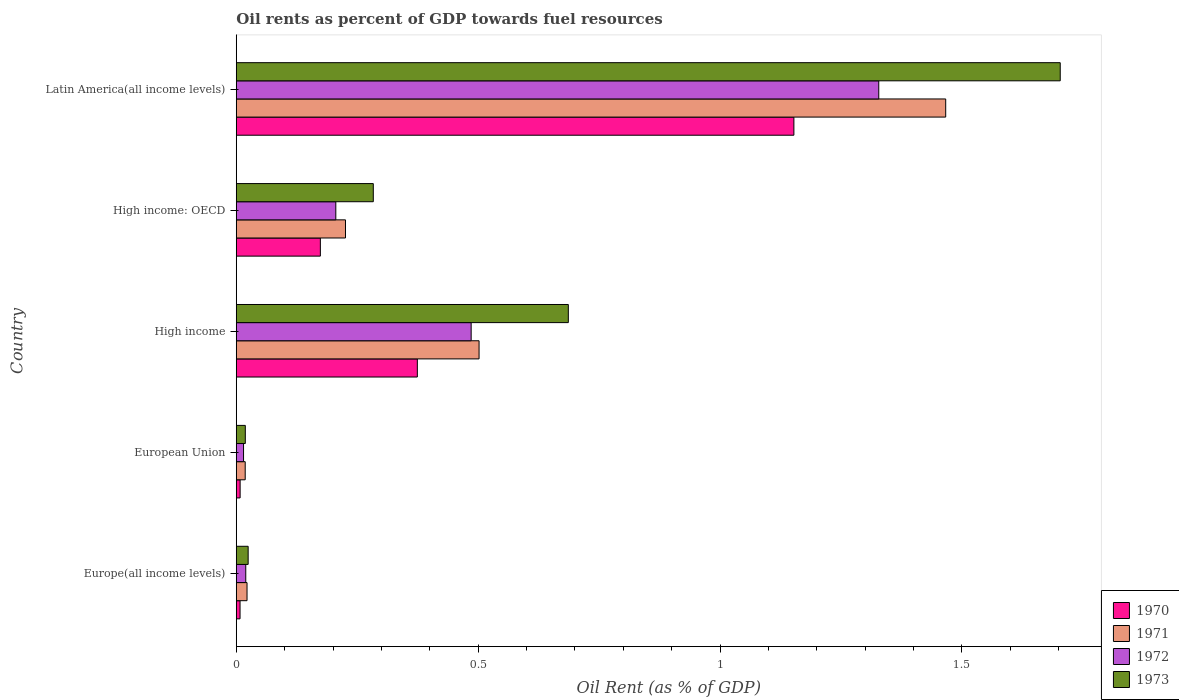How many groups of bars are there?
Offer a terse response. 5. Are the number of bars per tick equal to the number of legend labels?
Provide a short and direct response. Yes. How many bars are there on the 5th tick from the bottom?
Offer a very short reply. 4. In how many cases, is the number of bars for a given country not equal to the number of legend labels?
Offer a terse response. 0. What is the oil rent in 1970 in High income: OECD?
Your response must be concise. 0.17. Across all countries, what is the maximum oil rent in 1970?
Keep it short and to the point. 1.15. Across all countries, what is the minimum oil rent in 1972?
Offer a terse response. 0.02. In which country was the oil rent in 1973 maximum?
Your answer should be compact. Latin America(all income levels). In which country was the oil rent in 1970 minimum?
Offer a very short reply. Europe(all income levels). What is the total oil rent in 1972 in the graph?
Your answer should be very brief. 2.05. What is the difference between the oil rent in 1973 in High income: OECD and that in Latin America(all income levels)?
Offer a very short reply. -1.42. What is the difference between the oil rent in 1971 in Latin America(all income levels) and the oil rent in 1972 in High income: OECD?
Your answer should be very brief. 1.26. What is the average oil rent in 1971 per country?
Offer a terse response. 0.45. What is the difference between the oil rent in 1971 and oil rent in 1970 in European Union?
Offer a terse response. 0.01. What is the ratio of the oil rent in 1972 in Europe(all income levels) to that in Latin America(all income levels)?
Offer a very short reply. 0.01. Is the difference between the oil rent in 1971 in Europe(all income levels) and High income greater than the difference between the oil rent in 1970 in Europe(all income levels) and High income?
Your answer should be very brief. No. What is the difference between the highest and the second highest oil rent in 1971?
Your response must be concise. 0.96. What is the difference between the highest and the lowest oil rent in 1972?
Make the answer very short. 1.31. Is it the case that in every country, the sum of the oil rent in 1973 and oil rent in 1970 is greater than the oil rent in 1971?
Offer a very short reply. Yes. Are all the bars in the graph horizontal?
Keep it short and to the point. Yes. How many countries are there in the graph?
Give a very brief answer. 5. Does the graph contain any zero values?
Your answer should be very brief. No. Does the graph contain grids?
Make the answer very short. No. How are the legend labels stacked?
Offer a terse response. Vertical. What is the title of the graph?
Ensure brevity in your answer.  Oil rents as percent of GDP towards fuel resources. Does "2001" appear as one of the legend labels in the graph?
Give a very brief answer. No. What is the label or title of the X-axis?
Offer a terse response. Oil Rent (as % of GDP). What is the Oil Rent (as % of GDP) in 1970 in Europe(all income levels)?
Provide a succinct answer. 0.01. What is the Oil Rent (as % of GDP) in 1971 in Europe(all income levels)?
Offer a very short reply. 0.02. What is the Oil Rent (as % of GDP) of 1972 in Europe(all income levels)?
Ensure brevity in your answer.  0.02. What is the Oil Rent (as % of GDP) of 1973 in Europe(all income levels)?
Make the answer very short. 0.02. What is the Oil Rent (as % of GDP) of 1970 in European Union?
Your answer should be very brief. 0.01. What is the Oil Rent (as % of GDP) in 1971 in European Union?
Give a very brief answer. 0.02. What is the Oil Rent (as % of GDP) of 1972 in European Union?
Give a very brief answer. 0.02. What is the Oil Rent (as % of GDP) in 1973 in European Union?
Your response must be concise. 0.02. What is the Oil Rent (as % of GDP) in 1970 in High income?
Your answer should be compact. 0.37. What is the Oil Rent (as % of GDP) of 1971 in High income?
Ensure brevity in your answer.  0.5. What is the Oil Rent (as % of GDP) of 1972 in High income?
Offer a terse response. 0.49. What is the Oil Rent (as % of GDP) in 1973 in High income?
Give a very brief answer. 0.69. What is the Oil Rent (as % of GDP) in 1970 in High income: OECD?
Make the answer very short. 0.17. What is the Oil Rent (as % of GDP) in 1971 in High income: OECD?
Your answer should be very brief. 0.23. What is the Oil Rent (as % of GDP) in 1972 in High income: OECD?
Make the answer very short. 0.21. What is the Oil Rent (as % of GDP) in 1973 in High income: OECD?
Your answer should be compact. 0.28. What is the Oil Rent (as % of GDP) in 1970 in Latin America(all income levels)?
Give a very brief answer. 1.15. What is the Oil Rent (as % of GDP) in 1971 in Latin America(all income levels)?
Keep it short and to the point. 1.47. What is the Oil Rent (as % of GDP) in 1972 in Latin America(all income levels)?
Your answer should be compact. 1.33. What is the Oil Rent (as % of GDP) in 1973 in Latin America(all income levels)?
Your answer should be compact. 1.7. Across all countries, what is the maximum Oil Rent (as % of GDP) of 1970?
Your response must be concise. 1.15. Across all countries, what is the maximum Oil Rent (as % of GDP) in 1971?
Your answer should be compact. 1.47. Across all countries, what is the maximum Oil Rent (as % of GDP) of 1972?
Provide a succinct answer. 1.33. Across all countries, what is the maximum Oil Rent (as % of GDP) of 1973?
Keep it short and to the point. 1.7. Across all countries, what is the minimum Oil Rent (as % of GDP) in 1970?
Provide a short and direct response. 0.01. Across all countries, what is the minimum Oil Rent (as % of GDP) in 1971?
Provide a succinct answer. 0.02. Across all countries, what is the minimum Oil Rent (as % of GDP) of 1972?
Offer a very short reply. 0.02. Across all countries, what is the minimum Oil Rent (as % of GDP) of 1973?
Keep it short and to the point. 0.02. What is the total Oil Rent (as % of GDP) of 1970 in the graph?
Make the answer very short. 1.72. What is the total Oil Rent (as % of GDP) in 1971 in the graph?
Your response must be concise. 2.24. What is the total Oil Rent (as % of GDP) of 1972 in the graph?
Keep it short and to the point. 2.05. What is the total Oil Rent (as % of GDP) of 1973 in the graph?
Your response must be concise. 2.72. What is the difference between the Oil Rent (as % of GDP) in 1970 in Europe(all income levels) and that in European Union?
Keep it short and to the point. -0. What is the difference between the Oil Rent (as % of GDP) in 1971 in Europe(all income levels) and that in European Union?
Give a very brief answer. 0. What is the difference between the Oil Rent (as % of GDP) in 1972 in Europe(all income levels) and that in European Union?
Give a very brief answer. 0. What is the difference between the Oil Rent (as % of GDP) in 1973 in Europe(all income levels) and that in European Union?
Give a very brief answer. 0.01. What is the difference between the Oil Rent (as % of GDP) of 1970 in Europe(all income levels) and that in High income?
Ensure brevity in your answer.  -0.37. What is the difference between the Oil Rent (as % of GDP) in 1971 in Europe(all income levels) and that in High income?
Make the answer very short. -0.48. What is the difference between the Oil Rent (as % of GDP) of 1972 in Europe(all income levels) and that in High income?
Keep it short and to the point. -0.47. What is the difference between the Oil Rent (as % of GDP) of 1973 in Europe(all income levels) and that in High income?
Your response must be concise. -0.66. What is the difference between the Oil Rent (as % of GDP) in 1970 in Europe(all income levels) and that in High income: OECD?
Your answer should be very brief. -0.17. What is the difference between the Oil Rent (as % of GDP) of 1971 in Europe(all income levels) and that in High income: OECD?
Keep it short and to the point. -0.2. What is the difference between the Oil Rent (as % of GDP) of 1972 in Europe(all income levels) and that in High income: OECD?
Your response must be concise. -0.19. What is the difference between the Oil Rent (as % of GDP) of 1973 in Europe(all income levels) and that in High income: OECD?
Keep it short and to the point. -0.26. What is the difference between the Oil Rent (as % of GDP) in 1970 in Europe(all income levels) and that in Latin America(all income levels)?
Ensure brevity in your answer.  -1.14. What is the difference between the Oil Rent (as % of GDP) in 1971 in Europe(all income levels) and that in Latin America(all income levels)?
Keep it short and to the point. -1.44. What is the difference between the Oil Rent (as % of GDP) in 1972 in Europe(all income levels) and that in Latin America(all income levels)?
Your answer should be very brief. -1.31. What is the difference between the Oil Rent (as % of GDP) of 1973 in Europe(all income levels) and that in Latin America(all income levels)?
Your answer should be compact. -1.68. What is the difference between the Oil Rent (as % of GDP) in 1970 in European Union and that in High income?
Provide a succinct answer. -0.37. What is the difference between the Oil Rent (as % of GDP) in 1971 in European Union and that in High income?
Your response must be concise. -0.48. What is the difference between the Oil Rent (as % of GDP) in 1972 in European Union and that in High income?
Your answer should be compact. -0.47. What is the difference between the Oil Rent (as % of GDP) of 1973 in European Union and that in High income?
Your answer should be very brief. -0.67. What is the difference between the Oil Rent (as % of GDP) of 1970 in European Union and that in High income: OECD?
Your answer should be very brief. -0.17. What is the difference between the Oil Rent (as % of GDP) of 1971 in European Union and that in High income: OECD?
Provide a short and direct response. -0.21. What is the difference between the Oil Rent (as % of GDP) in 1972 in European Union and that in High income: OECD?
Offer a terse response. -0.19. What is the difference between the Oil Rent (as % of GDP) in 1973 in European Union and that in High income: OECD?
Keep it short and to the point. -0.26. What is the difference between the Oil Rent (as % of GDP) in 1970 in European Union and that in Latin America(all income levels)?
Keep it short and to the point. -1.14. What is the difference between the Oil Rent (as % of GDP) of 1971 in European Union and that in Latin America(all income levels)?
Make the answer very short. -1.45. What is the difference between the Oil Rent (as % of GDP) of 1972 in European Union and that in Latin America(all income levels)?
Ensure brevity in your answer.  -1.31. What is the difference between the Oil Rent (as % of GDP) of 1973 in European Union and that in Latin America(all income levels)?
Make the answer very short. -1.68. What is the difference between the Oil Rent (as % of GDP) in 1970 in High income and that in High income: OECD?
Provide a short and direct response. 0.2. What is the difference between the Oil Rent (as % of GDP) in 1971 in High income and that in High income: OECD?
Provide a short and direct response. 0.28. What is the difference between the Oil Rent (as % of GDP) of 1972 in High income and that in High income: OECD?
Your response must be concise. 0.28. What is the difference between the Oil Rent (as % of GDP) of 1973 in High income and that in High income: OECD?
Your answer should be compact. 0.4. What is the difference between the Oil Rent (as % of GDP) of 1970 in High income and that in Latin America(all income levels)?
Your answer should be very brief. -0.78. What is the difference between the Oil Rent (as % of GDP) of 1971 in High income and that in Latin America(all income levels)?
Your response must be concise. -0.96. What is the difference between the Oil Rent (as % of GDP) of 1972 in High income and that in Latin America(all income levels)?
Your answer should be compact. -0.84. What is the difference between the Oil Rent (as % of GDP) of 1973 in High income and that in Latin America(all income levels)?
Your answer should be compact. -1.02. What is the difference between the Oil Rent (as % of GDP) of 1970 in High income: OECD and that in Latin America(all income levels)?
Your answer should be compact. -0.98. What is the difference between the Oil Rent (as % of GDP) of 1971 in High income: OECD and that in Latin America(all income levels)?
Make the answer very short. -1.24. What is the difference between the Oil Rent (as % of GDP) in 1972 in High income: OECD and that in Latin America(all income levels)?
Your response must be concise. -1.12. What is the difference between the Oil Rent (as % of GDP) of 1973 in High income: OECD and that in Latin America(all income levels)?
Your answer should be very brief. -1.42. What is the difference between the Oil Rent (as % of GDP) of 1970 in Europe(all income levels) and the Oil Rent (as % of GDP) of 1971 in European Union?
Give a very brief answer. -0.01. What is the difference between the Oil Rent (as % of GDP) of 1970 in Europe(all income levels) and the Oil Rent (as % of GDP) of 1972 in European Union?
Give a very brief answer. -0.01. What is the difference between the Oil Rent (as % of GDP) in 1970 in Europe(all income levels) and the Oil Rent (as % of GDP) in 1973 in European Union?
Ensure brevity in your answer.  -0.01. What is the difference between the Oil Rent (as % of GDP) of 1971 in Europe(all income levels) and the Oil Rent (as % of GDP) of 1972 in European Union?
Keep it short and to the point. 0.01. What is the difference between the Oil Rent (as % of GDP) of 1971 in Europe(all income levels) and the Oil Rent (as % of GDP) of 1973 in European Union?
Give a very brief answer. 0. What is the difference between the Oil Rent (as % of GDP) of 1972 in Europe(all income levels) and the Oil Rent (as % of GDP) of 1973 in European Union?
Your answer should be compact. 0. What is the difference between the Oil Rent (as % of GDP) in 1970 in Europe(all income levels) and the Oil Rent (as % of GDP) in 1971 in High income?
Keep it short and to the point. -0.49. What is the difference between the Oil Rent (as % of GDP) of 1970 in Europe(all income levels) and the Oil Rent (as % of GDP) of 1972 in High income?
Give a very brief answer. -0.48. What is the difference between the Oil Rent (as % of GDP) of 1970 in Europe(all income levels) and the Oil Rent (as % of GDP) of 1973 in High income?
Provide a short and direct response. -0.68. What is the difference between the Oil Rent (as % of GDP) in 1971 in Europe(all income levels) and the Oil Rent (as % of GDP) in 1972 in High income?
Offer a terse response. -0.46. What is the difference between the Oil Rent (as % of GDP) in 1971 in Europe(all income levels) and the Oil Rent (as % of GDP) in 1973 in High income?
Offer a very short reply. -0.66. What is the difference between the Oil Rent (as % of GDP) in 1972 in Europe(all income levels) and the Oil Rent (as % of GDP) in 1973 in High income?
Give a very brief answer. -0.67. What is the difference between the Oil Rent (as % of GDP) of 1970 in Europe(all income levels) and the Oil Rent (as % of GDP) of 1971 in High income: OECD?
Your answer should be compact. -0.22. What is the difference between the Oil Rent (as % of GDP) in 1970 in Europe(all income levels) and the Oil Rent (as % of GDP) in 1972 in High income: OECD?
Offer a terse response. -0.2. What is the difference between the Oil Rent (as % of GDP) in 1970 in Europe(all income levels) and the Oil Rent (as % of GDP) in 1973 in High income: OECD?
Make the answer very short. -0.28. What is the difference between the Oil Rent (as % of GDP) of 1971 in Europe(all income levels) and the Oil Rent (as % of GDP) of 1972 in High income: OECD?
Make the answer very short. -0.18. What is the difference between the Oil Rent (as % of GDP) of 1971 in Europe(all income levels) and the Oil Rent (as % of GDP) of 1973 in High income: OECD?
Make the answer very short. -0.26. What is the difference between the Oil Rent (as % of GDP) in 1972 in Europe(all income levels) and the Oil Rent (as % of GDP) in 1973 in High income: OECD?
Offer a terse response. -0.26. What is the difference between the Oil Rent (as % of GDP) in 1970 in Europe(all income levels) and the Oil Rent (as % of GDP) in 1971 in Latin America(all income levels)?
Give a very brief answer. -1.46. What is the difference between the Oil Rent (as % of GDP) in 1970 in Europe(all income levels) and the Oil Rent (as % of GDP) in 1972 in Latin America(all income levels)?
Your answer should be compact. -1.32. What is the difference between the Oil Rent (as % of GDP) of 1970 in Europe(all income levels) and the Oil Rent (as % of GDP) of 1973 in Latin America(all income levels)?
Ensure brevity in your answer.  -1.7. What is the difference between the Oil Rent (as % of GDP) of 1971 in Europe(all income levels) and the Oil Rent (as % of GDP) of 1972 in Latin America(all income levels)?
Your answer should be very brief. -1.31. What is the difference between the Oil Rent (as % of GDP) of 1971 in Europe(all income levels) and the Oil Rent (as % of GDP) of 1973 in Latin America(all income levels)?
Make the answer very short. -1.68. What is the difference between the Oil Rent (as % of GDP) of 1972 in Europe(all income levels) and the Oil Rent (as % of GDP) of 1973 in Latin America(all income levels)?
Offer a very short reply. -1.68. What is the difference between the Oil Rent (as % of GDP) of 1970 in European Union and the Oil Rent (as % of GDP) of 1971 in High income?
Ensure brevity in your answer.  -0.49. What is the difference between the Oil Rent (as % of GDP) in 1970 in European Union and the Oil Rent (as % of GDP) in 1972 in High income?
Keep it short and to the point. -0.48. What is the difference between the Oil Rent (as % of GDP) of 1970 in European Union and the Oil Rent (as % of GDP) of 1973 in High income?
Your response must be concise. -0.68. What is the difference between the Oil Rent (as % of GDP) of 1971 in European Union and the Oil Rent (as % of GDP) of 1972 in High income?
Give a very brief answer. -0.47. What is the difference between the Oil Rent (as % of GDP) of 1971 in European Union and the Oil Rent (as % of GDP) of 1973 in High income?
Your answer should be very brief. -0.67. What is the difference between the Oil Rent (as % of GDP) in 1972 in European Union and the Oil Rent (as % of GDP) in 1973 in High income?
Your response must be concise. -0.67. What is the difference between the Oil Rent (as % of GDP) in 1970 in European Union and the Oil Rent (as % of GDP) in 1971 in High income: OECD?
Ensure brevity in your answer.  -0.22. What is the difference between the Oil Rent (as % of GDP) of 1970 in European Union and the Oil Rent (as % of GDP) of 1972 in High income: OECD?
Give a very brief answer. -0.2. What is the difference between the Oil Rent (as % of GDP) in 1970 in European Union and the Oil Rent (as % of GDP) in 1973 in High income: OECD?
Provide a succinct answer. -0.28. What is the difference between the Oil Rent (as % of GDP) in 1971 in European Union and the Oil Rent (as % of GDP) in 1972 in High income: OECD?
Your answer should be compact. -0.19. What is the difference between the Oil Rent (as % of GDP) in 1971 in European Union and the Oil Rent (as % of GDP) in 1973 in High income: OECD?
Your answer should be compact. -0.26. What is the difference between the Oil Rent (as % of GDP) in 1972 in European Union and the Oil Rent (as % of GDP) in 1973 in High income: OECD?
Ensure brevity in your answer.  -0.27. What is the difference between the Oil Rent (as % of GDP) of 1970 in European Union and the Oil Rent (as % of GDP) of 1971 in Latin America(all income levels)?
Ensure brevity in your answer.  -1.46. What is the difference between the Oil Rent (as % of GDP) in 1970 in European Union and the Oil Rent (as % of GDP) in 1972 in Latin America(all income levels)?
Ensure brevity in your answer.  -1.32. What is the difference between the Oil Rent (as % of GDP) of 1970 in European Union and the Oil Rent (as % of GDP) of 1973 in Latin America(all income levels)?
Give a very brief answer. -1.7. What is the difference between the Oil Rent (as % of GDP) of 1971 in European Union and the Oil Rent (as % of GDP) of 1972 in Latin America(all income levels)?
Your response must be concise. -1.31. What is the difference between the Oil Rent (as % of GDP) in 1971 in European Union and the Oil Rent (as % of GDP) in 1973 in Latin America(all income levels)?
Offer a terse response. -1.68. What is the difference between the Oil Rent (as % of GDP) of 1972 in European Union and the Oil Rent (as % of GDP) of 1973 in Latin America(all income levels)?
Your answer should be compact. -1.69. What is the difference between the Oil Rent (as % of GDP) of 1970 in High income and the Oil Rent (as % of GDP) of 1971 in High income: OECD?
Your answer should be very brief. 0.15. What is the difference between the Oil Rent (as % of GDP) of 1970 in High income and the Oil Rent (as % of GDP) of 1972 in High income: OECD?
Your answer should be compact. 0.17. What is the difference between the Oil Rent (as % of GDP) of 1970 in High income and the Oil Rent (as % of GDP) of 1973 in High income: OECD?
Your response must be concise. 0.09. What is the difference between the Oil Rent (as % of GDP) of 1971 in High income and the Oil Rent (as % of GDP) of 1972 in High income: OECD?
Offer a very short reply. 0.3. What is the difference between the Oil Rent (as % of GDP) of 1971 in High income and the Oil Rent (as % of GDP) of 1973 in High income: OECD?
Keep it short and to the point. 0.22. What is the difference between the Oil Rent (as % of GDP) of 1972 in High income and the Oil Rent (as % of GDP) of 1973 in High income: OECD?
Your answer should be very brief. 0.2. What is the difference between the Oil Rent (as % of GDP) of 1970 in High income and the Oil Rent (as % of GDP) of 1971 in Latin America(all income levels)?
Offer a terse response. -1.09. What is the difference between the Oil Rent (as % of GDP) of 1970 in High income and the Oil Rent (as % of GDP) of 1972 in Latin America(all income levels)?
Provide a short and direct response. -0.95. What is the difference between the Oil Rent (as % of GDP) in 1970 in High income and the Oil Rent (as % of GDP) in 1973 in Latin America(all income levels)?
Provide a succinct answer. -1.33. What is the difference between the Oil Rent (as % of GDP) in 1971 in High income and the Oil Rent (as % of GDP) in 1972 in Latin America(all income levels)?
Give a very brief answer. -0.83. What is the difference between the Oil Rent (as % of GDP) in 1971 in High income and the Oil Rent (as % of GDP) in 1973 in Latin America(all income levels)?
Your answer should be compact. -1.2. What is the difference between the Oil Rent (as % of GDP) of 1972 in High income and the Oil Rent (as % of GDP) of 1973 in Latin America(all income levels)?
Ensure brevity in your answer.  -1.22. What is the difference between the Oil Rent (as % of GDP) of 1970 in High income: OECD and the Oil Rent (as % of GDP) of 1971 in Latin America(all income levels)?
Provide a succinct answer. -1.29. What is the difference between the Oil Rent (as % of GDP) in 1970 in High income: OECD and the Oil Rent (as % of GDP) in 1972 in Latin America(all income levels)?
Ensure brevity in your answer.  -1.15. What is the difference between the Oil Rent (as % of GDP) of 1970 in High income: OECD and the Oil Rent (as % of GDP) of 1973 in Latin America(all income levels)?
Your response must be concise. -1.53. What is the difference between the Oil Rent (as % of GDP) in 1971 in High income: OECD and the Oil Rent (as % of GDP) in 1972 in Latin America(all income levels)?
Give a very brief answer. -1.1. What is the difference between the Oil Rent (as % of GDP) of 1971 in High income: OECD and the Oil Rent (as % of GDP) of 1973 in Latin America(all income levels)?
Ensure brevity in your answer.  -1.48. What is the difference between the Oil Rent (as % of GDP) in 1972 in High income: OECD and the Oil Rent (as % of GDP) in 1973 in Latin America(all income levels)?
Offer a terse response. -1.5. What is the average Oil Rent (as % of GDP) of 1970 per country?
Your response must be concise. 0.34. What is the average Oil Rent (as % of GDP) of 1971 per country?
Provide a succinct answer. 0.45. What is the average Oil Rent (as % of GDP) of 1972 per country?
Make the answer very short. 0.41. What is the average Oil Rent (as % of GDP) in 1973 per country?
Your response must be concise. 0.54. What is the difference between the Oil Rent (as % of GDP) of 1970 and Oil Rent (as % of GDP) of 1971 in Europe(all income levels)?
Make the answer very short. -0.01. What is the difference between the Oil Rent (as % of GDP) of 1970 and Oil Rent (as % of GDP) of 1972 in Europe(all income levels)?
Provide a short and direct response. -0.01. What is the difference between the Oil Rent (as % of GDP) of 1970 and Oil Rent (as % of GDP) of 1973 in Europe(all income levels)?
Provide a succinct answer. -0.02. What is the difference between the Oil Rent (as % of GDP) of 1971 and Oil Rent (as % of GDP) of 1972 in Europe(all income levels)?
Your response must be concise. 0. What is the difference between the Oil Rent (as % of GDP) of 1971 and Oil Rent (as % of GDP) of 1973 in Europe(all income levels)?
Your answer should be compact. -0. What is the difference between the Oil Rent (as % of GDP) in 1972 and Oil Rent (as % of GDP) in 1973 in Europe(all income levels)?
Your response must be concise. -0.01. What is the difference between the Oil Rent (as % of GDP) in 1970 and Oil Rent (as % of GDP) in 1971 in European Union?
Keep it short and to the point. -0.01. What is the difference between the Oil Rent (as % of GDP) of 1970 and Oil Rent (as % of GDP) of 1972 in European Union?
Provide a succinct answer. -0.01. What is the difference between the Oil Rent (as % of GDP) in 1970 and Oil Rent (as % of GDP) in 1973 in European Union?
Provide a succinct answer. -0.01. What is the difference between the Oil Rent (as % of GDP) in 1971 and Oil Rent (as % of GDP) in 1972 in European Union?
Ensure brevity in your answer.  0. What is the difference between the Oil Rent (as % of GDP) of 1971 and Oil Rent (as % of GDP) of 1973 in European Union?
Provide a succinct answer. -0. What is the difference between the Oil Rent (as % of GDP) of 1972 and Oil Rent (as % of GDP) of 1973 in European Union?
Make the answer very short. -0. What is the difference between the Oil Rent (as % of GDP) in 1970 and Oil Rent (as % of GDP) in 1971 in High income?
Offer a terse response. -0.13. What is the difference between the Oil Rent (as % of GDP) of 1970 and Oil Rent (as % of GDP) of 1972 in High income?
Provide a short and direct response. -0.11. What is the difference between the Oil Rent (as % of GDP) of 1970 and Oil Rent (as % of GDP) of 1973 in High income?
Offer a very short reply. -0.31. What is the difference between the Oil Rent (as % of GDP) of 1971 and Oil Rent (as % of GDP) of 1972 in High income?
Ensure brevity in your answer.  0.02. What is the difference between the Oil Rent (as % of GDP) in 1971 and Oil Rent (as % of GDP) in 1973 in High income?
Your answer should be compact. -0.18. What is the difference between the Oil Rent (as % of GDP) of 1972 and Oil Rent (as % of GDP) of 1973 in High income?
Provide a succinct answer. -0.2. What is the difference between the Oil Rent (as % of GDP) in 1970 and Oil Rent (as % of GDP) in 1971 in High income: OECD?
Make the answer very short. -0.05. What is the difference between the Oil Rent (as % of GDP) of 1970 and Oil Rent (as % of GDP) of 1972 in High income: OECD?
Your response must be concise. -0.03. What is the difference between the Oil Rent (as % of GDP) of 1970 and Oil Rent (as % of GDP) of 1973 in High income: OECD?
Offer a very short reply. -0.11. What is the difference between the Oil Rent (as % of GDP) of 1971 and Oil Rent (as % of GDP) of 1973 in High income: OECD?
Provide a short and direct response. -0.06. What is the difference between the Oil Rent (as % of GDP) in 1972 and Oil Rent (as % of GDP) in 1973 in High income: OECD?
Ensure brevity in your answer.  -0.08. What is the difference between the Oil Rent (as % of GDP) in 1970 and Oil Rent (as % of GDP) in 1971 in Latin America(all income levels)?
Offer a terse response. -0.31. What is the difference between the Oil Rent (as % of GDP) of 1970 and Oil Rent (as % of GDP) of 1972 in Latin America(all income levels)?
Your answer should be compact. -0.18. What is the difference between the Oil Rent (as % of GDP) in 1970 and Oil Rent (as % of GDP) in 1973 in Latin America(all income levels)?
Give a very brief answer. -0.55. What is the difference between the Oil Rent (as % of GDP) in 1971 and Oil Rent (as % of GDP) in 1972 in Latin America(all income levels)?
Provide a succinct answer. 0.14. What is the difference between the Oil Rent (as % of GDP) in 1971 and Oil Rent (as % of GDP) in 1973 in Latin America(all income levels)?
Offer a terse response. -0.24. What is the difference between the Oil Rent (as % of GDP) in 1972 and Oil Rent (as % of GDP) in 1973 in Latin America(all income levels)?
Offer a terse response. -0.38. What is the ratio of the Oil Rent (as % of GDP) of 1970 in Europe(all income levels) to that in European Union?
Give a very brief answer. 0.98. What is the ratio of the Oil Rent (as % of GDP) of 1971 in Europe(all income levels) to that in European Union?
Offer a very short reply. 1.2. What is the ratio of the Oil Rent (as % of GDP) in 1972 in Europe(all income levels) to that in European Union?
Provide a succinct answer. 1.3. What is the ratio of the Oil Rent (as % of GDP) in 1973 in Europe(all income levels) to that in European Union?
Your answer should be very brief. 1.31. What is the ratio of the Oil Rent (as % of GDP) in 1970 in Europe(all income levels) to that in High income?
Provide a short and direct response. 0.02. What is the ratio of the Oil Rent (as % of GDP) of 1971 in Europe(all income levels) to that in High income?
Your answer should be compact. 0.04. What is the ratio of the Oil Rent (as % of GDP) in 1972 in Europe(all income levels) to that in High income?
Ensure brevity in your answer.  0.04. What is the ratio of the Oil Rent (as % of GDP) of 1973 in Europe(all income levels) to that in High income?
Give a very brief answer. 0.04. What is the ratio of the Oil Rent (as % of GDP) in 1970 in Europe(all income levels) to that in High income: OECD?
Offer a very short reply. 0.05. What is the ratio of the Oil Rent (as % of GDP) of 1971 in Europe(all income levels) to that in High income: OECD?
Ensure brevity in your answer.  0.1. What is the ratio of the Oil Rent (as % of GDP) in 1972 in Europe(all income levels) to that in High income: OECD?
Give a very brief answer. 0.1. What is the ratio of the Oil Rent (as % of GDP) of 1973 in Europe(all income levels) to that in High income: OECD?
Your response must be concise. 0.09. What is the ratio of the Oil Rent (as % of GDP) of 1970 in Europe(all income levels) to that in Latin America(all income levels)?
Ensure brevity in your answer.  0.01. What is the ratio of the Oil Rent (as % of GDP) in 1971 in Europe(all income levels) to that in Latin America(all income levels)?
Keep it short and to the point. 0.02. What is the ratio of the Oil Rent (as % of GDP) in 1972 in Europe(all income levels) to that in Latin America(all income levels)?
Your answer should be very brief. 0.01. What is the ratio of the Oil Rent (as % of GDP) in 1973 in Europe(all income levels) to that in Latin America(all income levels)?
Give a very brief answer. 0.01. What is the ratio of the Oil Rent (as % of GDP) of 1970 in European Union to that in High income?
Offer a terse response. 0.02. What is the ratio of the Oil Rent (as % of GDP) of 1971 in European Union to that in High income?
Your answer should be very brief. 0.04. What is the ratio of the Oil Rent (as % of GDP) in 1972 in European Union to that in High income?
Your answer should be very brief. 0.03. What is the ratio of the Oil Rent (as % of GDP) of 1973 in European Union to that in High income?
Keep it short and to the point. 0.03. What is the ratio of the Oil Rent (as % of GDP) in 1970 in European Union to that in High income: OECD?
Provide a short and direct response. 0.05. What is the ratio of the Oil Rent (as % of GDP) of 1971 in European Union to that in High income: OECD?
Make the answer very short. 0.08. What is the ratio of the Oil Rent (as % of GDP) in 1972 in European Union to that in High income: OECD?
Provide a succinct answer. 0.07. What is the ratio of the Oil Rent (as % of GDP) in 1973 in European Union to that in High income: OECD?
Make the answer very short. 0.07. What is the ratio of the Oil Rent (as % of GDP) of 1970 in European Union to that in Latin America(all income levels)?
Your answer should be very brief. 0.01. What is the ratio of the Oil Rent (as % of GDP) of 1971 in European Union to that in Latin America(all income levels)?
Your response must be concise. 0.01. What is the ratio of the Oil Rent (as % of GDP) in 1972 in European Union to that in Latin America(all income levels)?
Make the answer very short. 0.01. What is the ratio of the Oil Rent (as % of GDP) in 1973 in European Union to that in Latin America(all income levels)?
Provide a succinct answer. 0.01. What is the ratio of the Oil Rent (as % of GDP) of 1970 in High income to that in High income: OECD?
Your answer should be compact. 2.15. What is the ratio of the Oil Rent (as % of GDP) of 1971 in High income to that in High income: OECD?
Your answer should be compact. 2.22. What is the ratio of the Oil Rent (as % of GDP) of 1972 in High income to that in High income: OECD?
Offer a terse response. 2.36. What is the ratio of the Oil Rent (as % of GDP) of 1973 in High income to that in High income: OECD?
Offer a terse response. 2.42. What is the ratio of the Oil Rent (as % of GDP) of 1970 in High income to that in Latin America(all income levels)?
Offer a terse response. 0.32. What is the ratio of the Oil Rent (as % of GDP) in 1971 in High income to that in Latin America(all income levels)?
Provide a short and direct response. 0.34. What is the ratio of the Oil Rent (as % of GDP) in 1972 in High income to that in Latin America(all income levels)?
Your answer should be compact. 0.37. What is the ratio of the Oil Rent (as % of GDP) of 1973 in High income to that in Latin America(all income levels)?
Make the answer very short. 0.4. What is the ratio of the Oil Rent (as % of GDP) in 1970 in High income: OECD to that in Latin America(all income levels)?
Ensure brevity in your answer.  0.15. What is the ratio of the Oil Rent (as % of GDP) of 1971 in High income: OECD to that in Latin America(all income levels)?
Your answer should be compact. 0.15. What is the ratio of the Oil Rent (as % of GDP) of 1972 in High income: OECD to that in Latin America(all income levels)?
Ensure brevity in your answer.  0.15. What is the ratio of the Oil Rent (as % of GDP) of 1973 in High income: OECD to that in Latin America(all income levels)?
Give a very brief answer. 0.17. What is the difference between the highest and the second highest Oil Rent (as % of GDP) in 1970?
Make the answer very short. 0.78. What is the difference between the highest and the second highest Oil Rent (as % of GDP) of 1971?
Keep it short and to the point. 0.96. What is the difference between the highest and the second highest Oil Rent (as % of GDP) in 1972?
Offer a terse response. 0.84. What is the difference between the highest and the second highest Oil Rent (as % of GDP) of 1973?
Give a very brief answer. 1.02. What is the difference between the highest and the lowest Oil Rent (as % of GDP) of 1970?
Your response must be concise. 1.14. What is the difference between the highest and the lowest Oil Rent (as % of GDP) of 1971?
Make the answer very short. 1.45. What is the difference between the highest and the lowest Oil Rent (as % of GDP) in 1972?
Offer a terse response. 1.31. What is the difference between the highest and the lowest Oil Rent (as % of GDP) of 1973?
Make the answer very short. 1.68. 